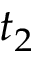<formula> <loc_0><loc_0><loc_500><loc_500>t _ { 2 }</formula> 